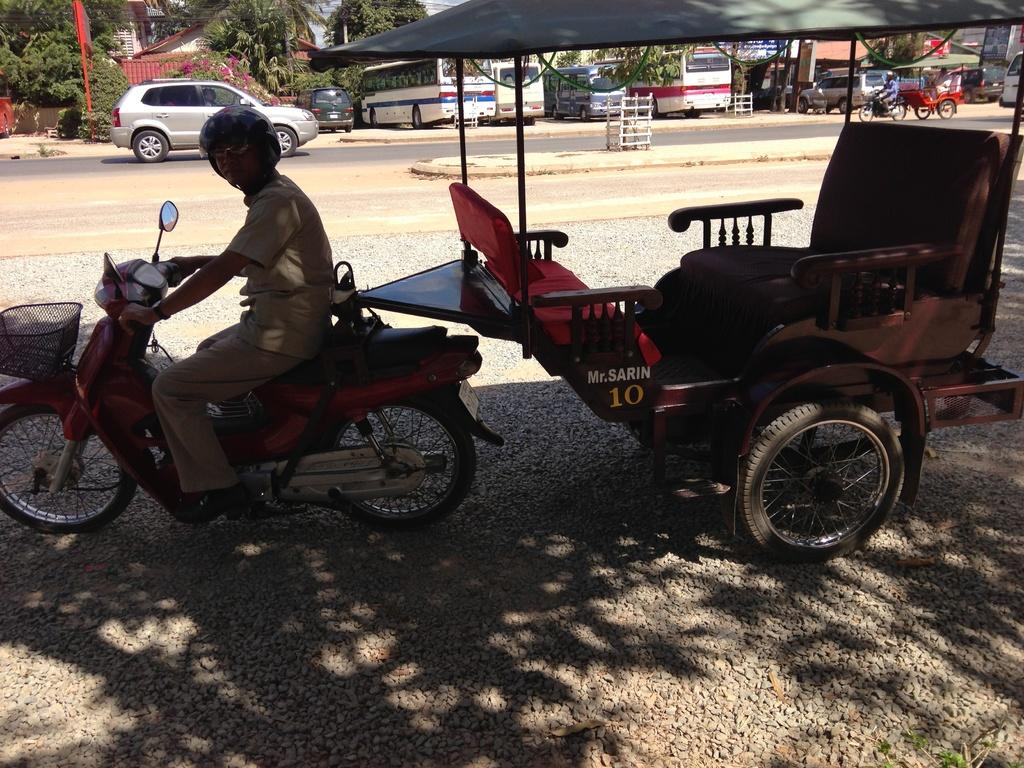What type of vehicle is in the image? There is a cart in the image. What other vehicles are present in the image? There are people on motorcycles in the image. Where are the cart and motorcycles located? The cart and motorcycles are on a road. What can be seen in the background of the image? There are vehicles, buildings, trees, and some unspecified objects in the background of the image. Can you tell me how many snakes are slithering on the road in the image? There are no snakes present in the image; the vehicles in the image are a cart and motorcycles. What type of wash is being performed on the vehicles in the image? There is no indication of any washing activity in the image; the vehicles are simply on the road. 